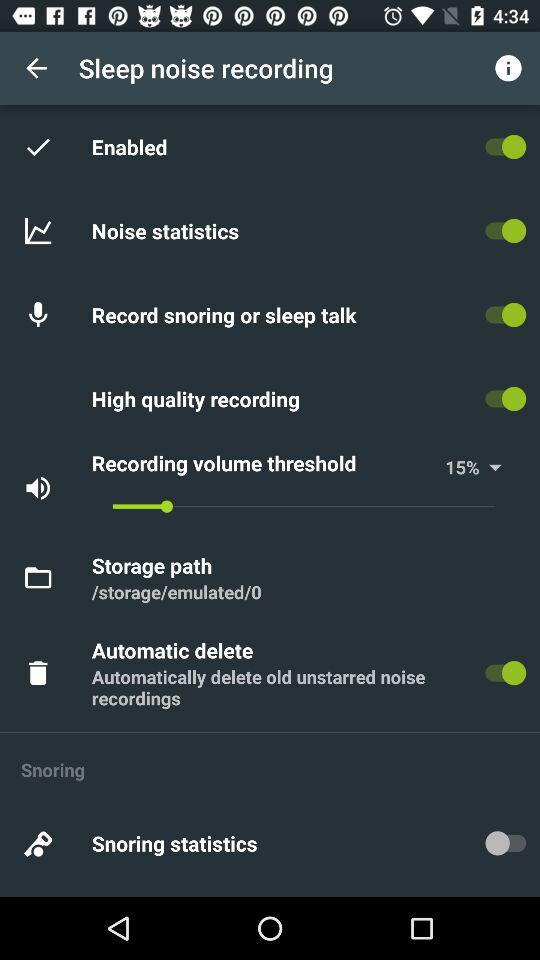What is the selected value for "Recording volume threshold" in percentage? The selected value for "Recording volume threshold" in percentage is 15. 